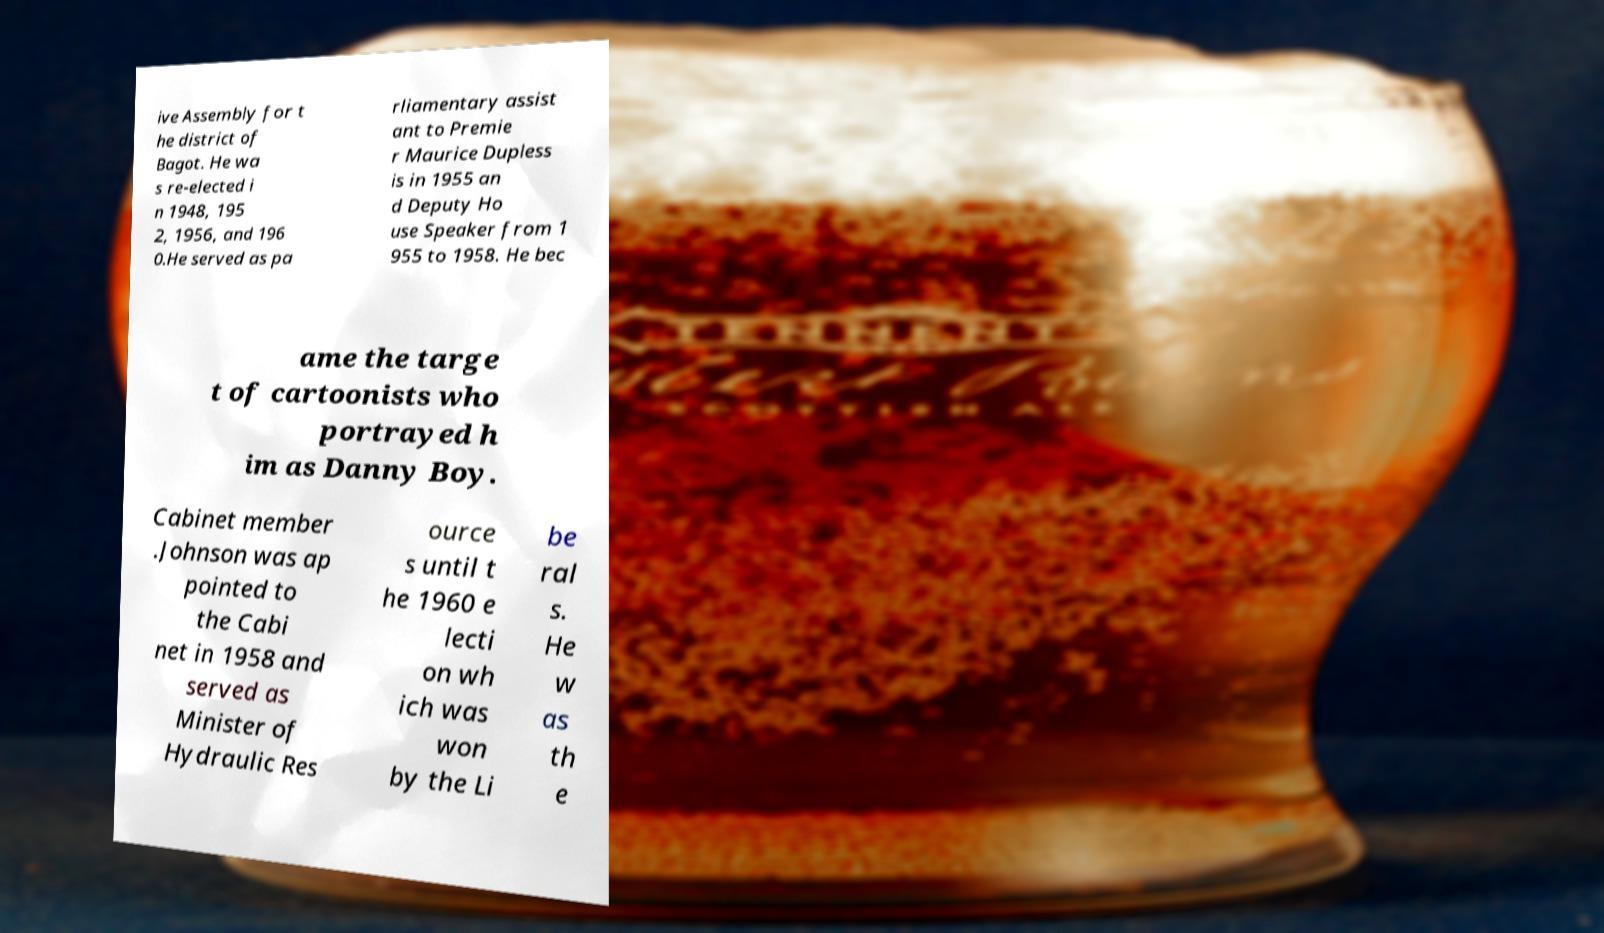Can you accurately transcribe the text from the provided image for me? ive Assembly for t he district of Bagot. He wa s re-elected i n 1948, 195 2, 1956, and 196 0.He served as pa rliamentary assist ant to Premie r Maurice Dupless is in 1955 an d Deputy Ho use Speaker from 1 955 to 1958. He bec ame the targe t of cartoonists who portrayed h im as Danny Boy. Cabinet member .Johnson was ap pointed to the Cabi net in 1958 and served as Minister of Hydraulic Res ource s until t he 1960 e lecti on wh ich was won by the Li be ral s. He w as th e 